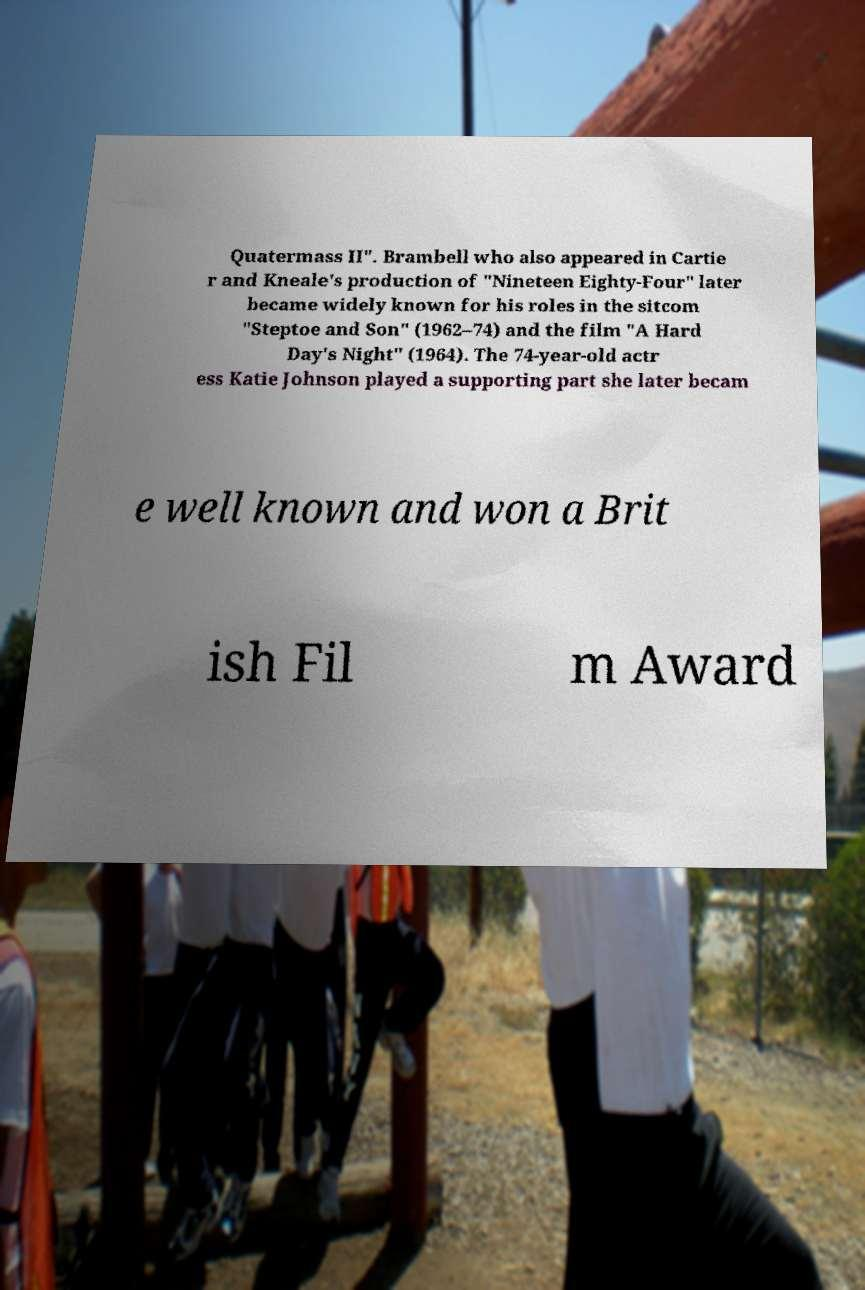There's text embedded in this image that I need extracted. Can you transcribe it verbatim? Quatermass II". Brambell who also appeared in Cartie r and Kneale's production of "Nineteen Eighty-Four" later became widely known for his roles in the sitcom "Steptoe and Son" (1962–74) and the film "A Hard Day's Night" (1964). The 74-year-old actr ess Katie Johnson played a supporting part she later becam e well known and won a Brit ish Fil m Award 